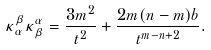Convert formula to latex. <formula><loc_0><loc_0><loc_500><loc_500>\kappa _ { \alpha } ^ { \beta } \kappa _ { \beta } ^ { \alpha } = \frac { 3 m ^ { 2 } } { t ^ { 2 } } + \frac { 2 m ( n - m ) b } { t ^ { m - n + 2 } } .</formula> 